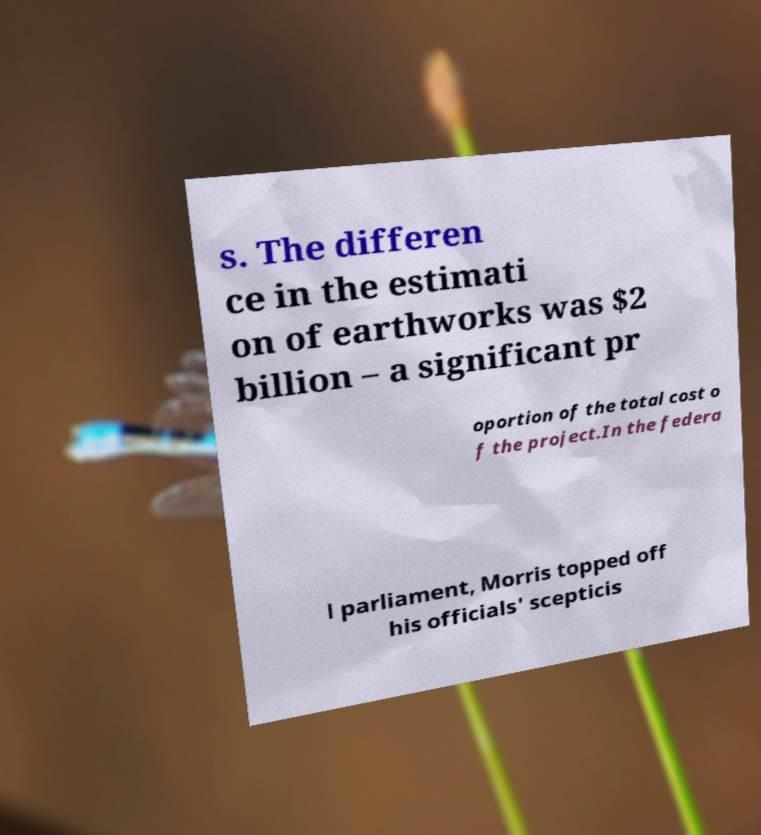Could you extract and type out the text from this image? s. The differen ce in the estimati on of earthworks was $2 billion – a significant pr oportion of the total cost o f the project.In the federa l parliament, Morris topped off his officials' scepticis 